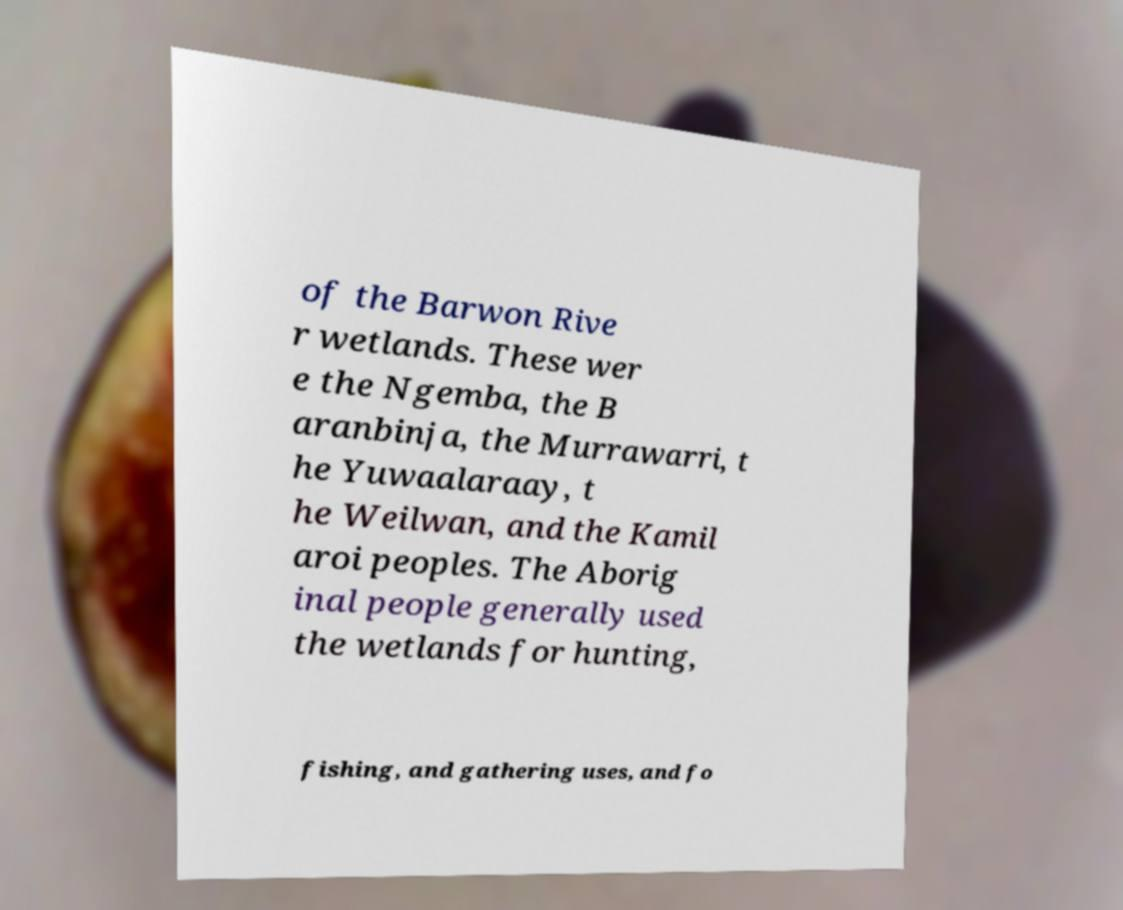Can you read and provide the text displayed in the image?This photo seems to have some interesting text. Can you extract and type it out for me? of the Barwon Rive r wetlands. These wer e the Ngemba, the B aranbinja, the Murrawarri, t he Yuwaalaraay, t he Weilwan, and the Kamil aroi peoples. The Aborig inal people generally used the wetlands for hunting, fishing, and gathering uses, and fo 